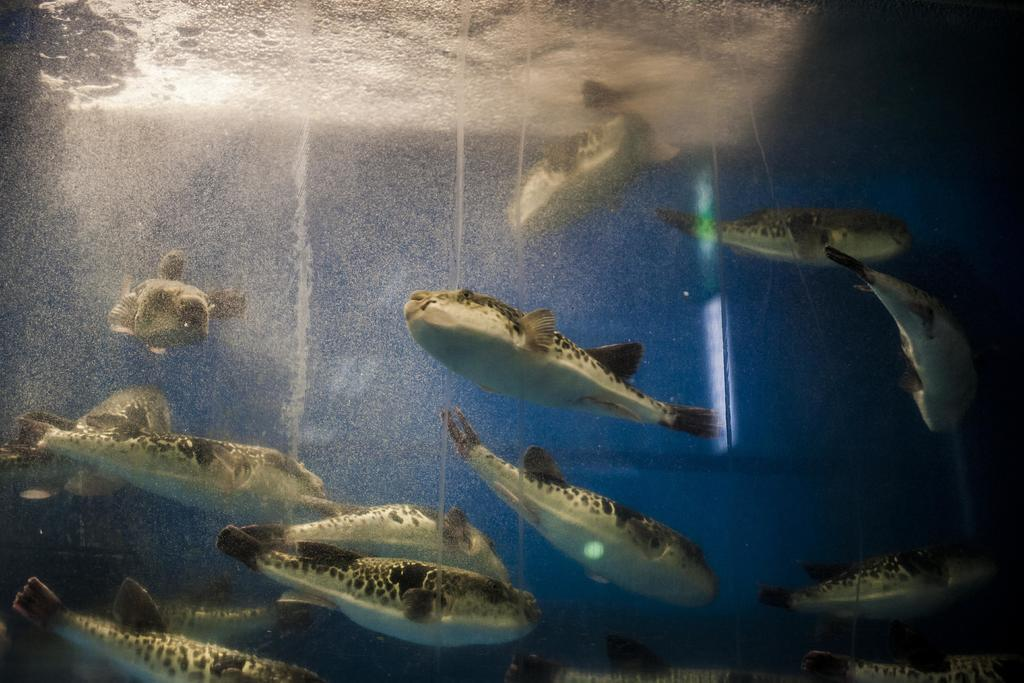What type of animals can be seen in the image? There are many fishes in the image. Where are the fishes located? The fishes are swimming in a water body. How many tickets are required to enter the water body in the image? There is no mention of tickets or any entrance requirement in the image; it simply shows fishes swimming in a water body. 